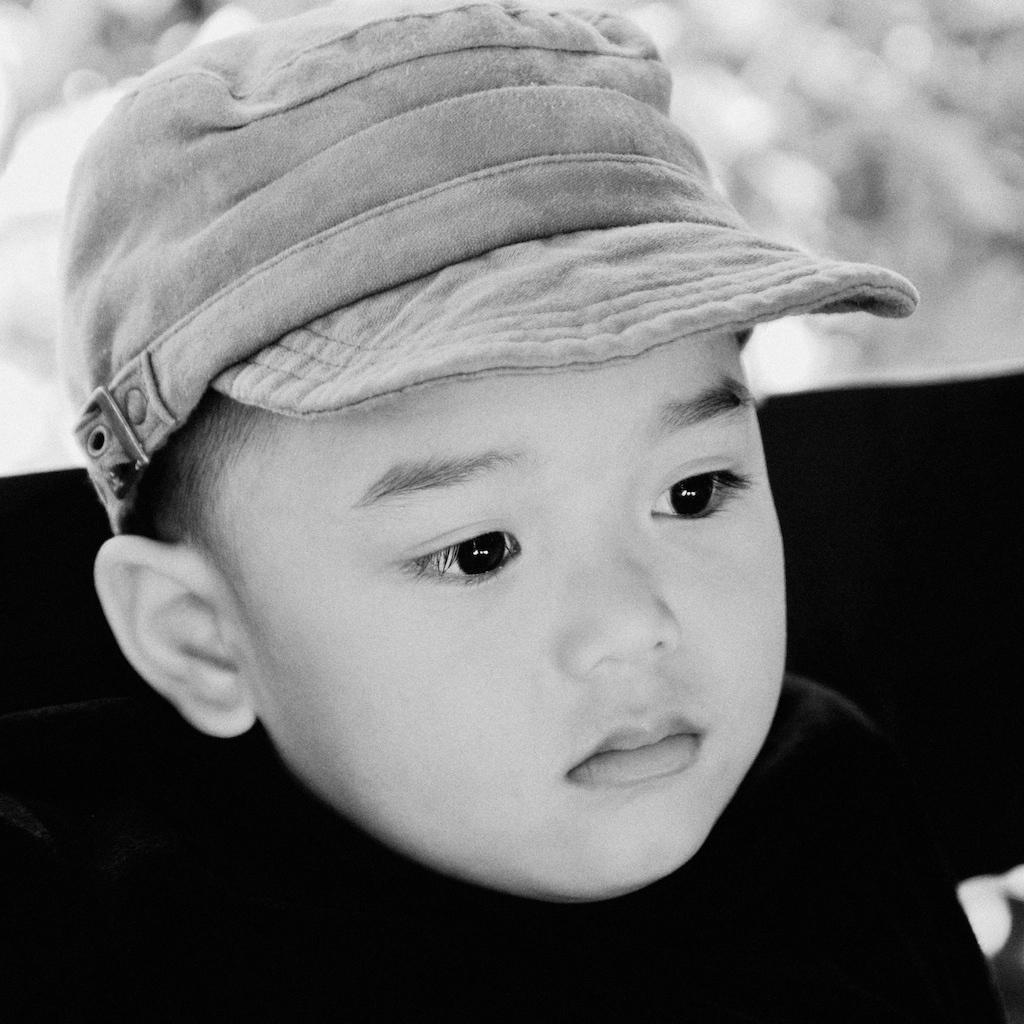What is the main subject of the image? There is a baby in the image. What is the baby wearing on their head? The baby is wearing a cap. What is the color scheme of the image? The image is in black and white. What type of feather is holding in the image? There is no feather or l in the image; it features a baby wearing a cap in a black and white image. 